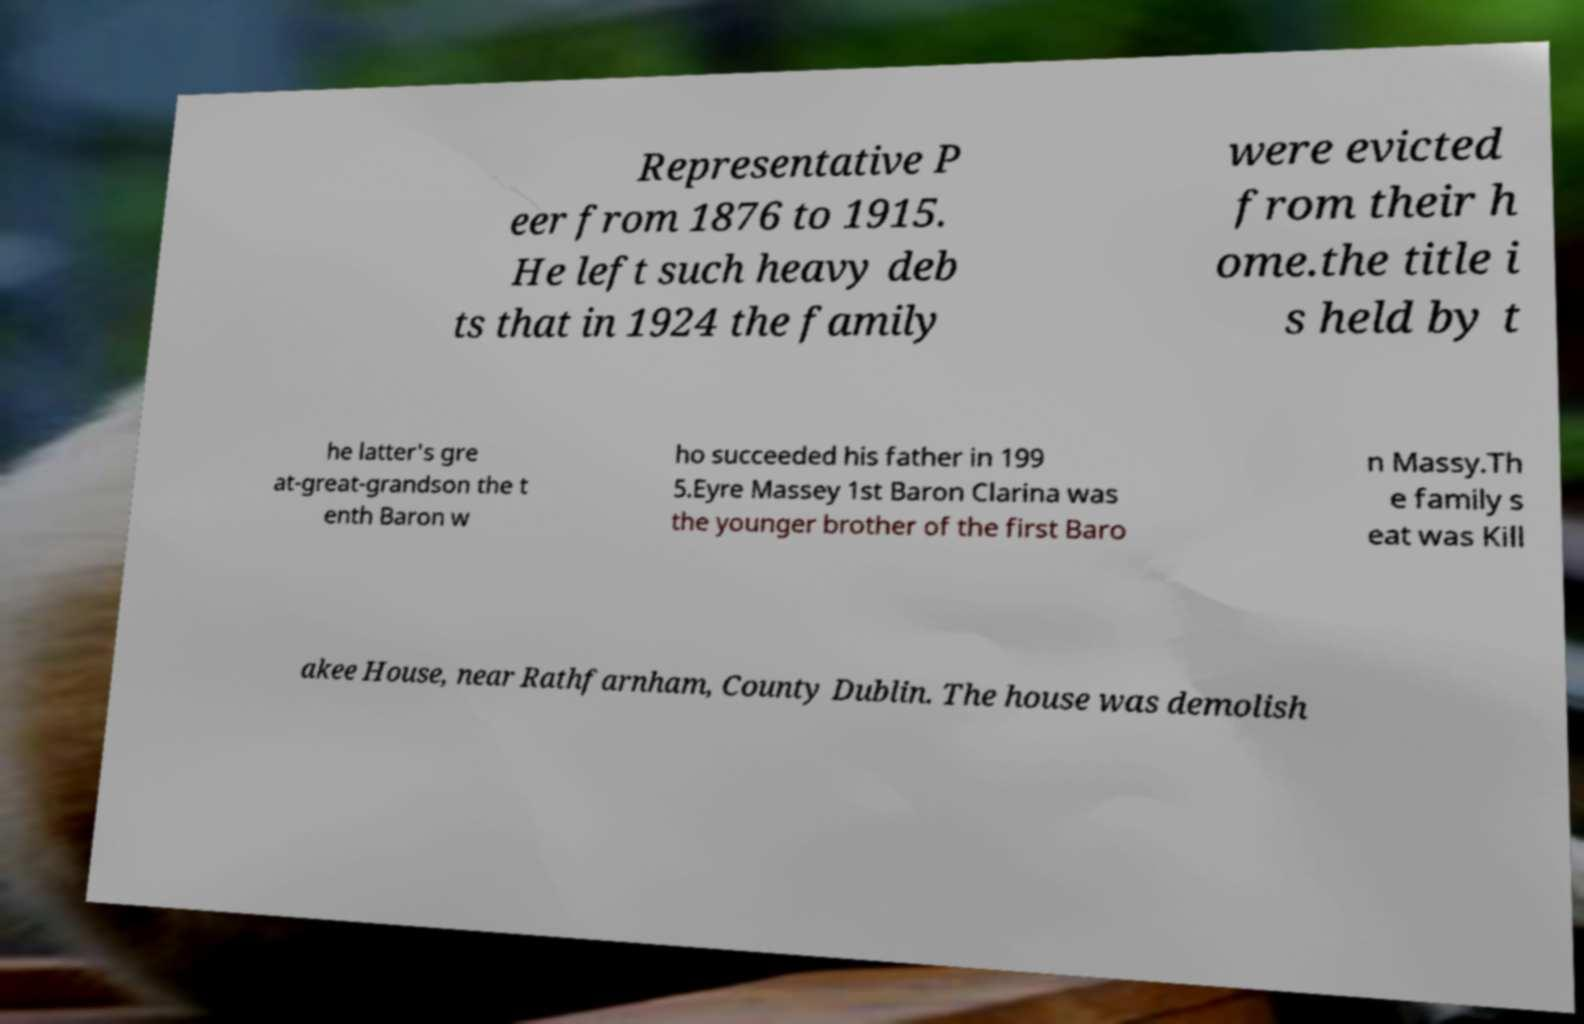Please identify and transcribe the text found in this image. Representative P eer from 1876 to 1915. He left such heavy deb ts that in 1924 the family were evicted from their h ome.the title i s held by t he latter's gre at-great-grandson the t enth Baron w ho succeeded his father in 199 5.Eyre Massey 1st Baron Clarina was the younger brother of the first Baro n Massy.Th e family s eat was Kill akee House, near Rathfarnham, County Dublin. The house was demolish 